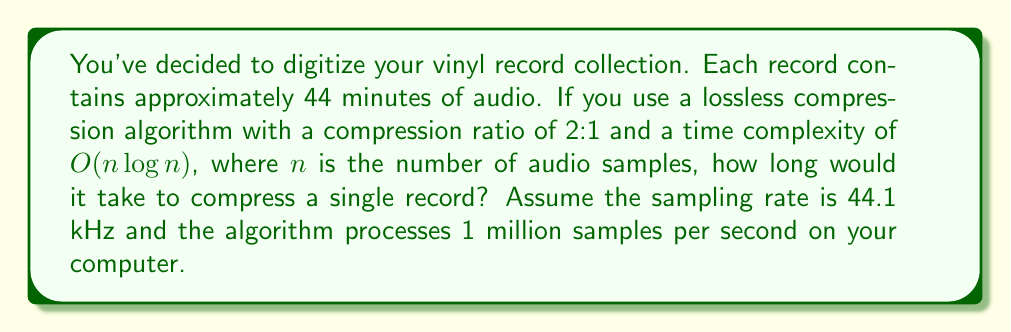Provide a solution to this math problem. Let's break this down step-by-step:

1) First, calculate the total number of samples in a record:
   - Duration: 44 minutes = 2640 seconds
   - Sampling rate: 44.1 kHz = 44,100 samples/second
   - Total samples: $n = 2640 \times 44100 = 116,424,000$ samples

2) The time complexity is $O(n \log n)$. For large $n$, we can approximate the actual number of operations as $c \cdot n \log n$, where $c$ is some constant. Let's assume $c = 1$ for simplicity.

3) Calculate $n \log n$:
   $116,424,000 \times \log_2(116,424,000) \approx 3.14 \times 10^9$

4) The algorithm processes 1 million samples per second, which means it performs $10^6$ operations per second.

5) Time to compress = (Number of operations) / (Operations per second)
   $$ \text{Time} = \frac{3.14 \times 10^9}{10^6} = 3140 \text{ seconds} $$

6) Convert to minutes:
   $$ 3140 \text{ seconds} = 52.33 \text{ minutes} $$

Therefore, it would take approximately 52.33 minutes to compress a single record.
Answer: $52.33$ minutes 